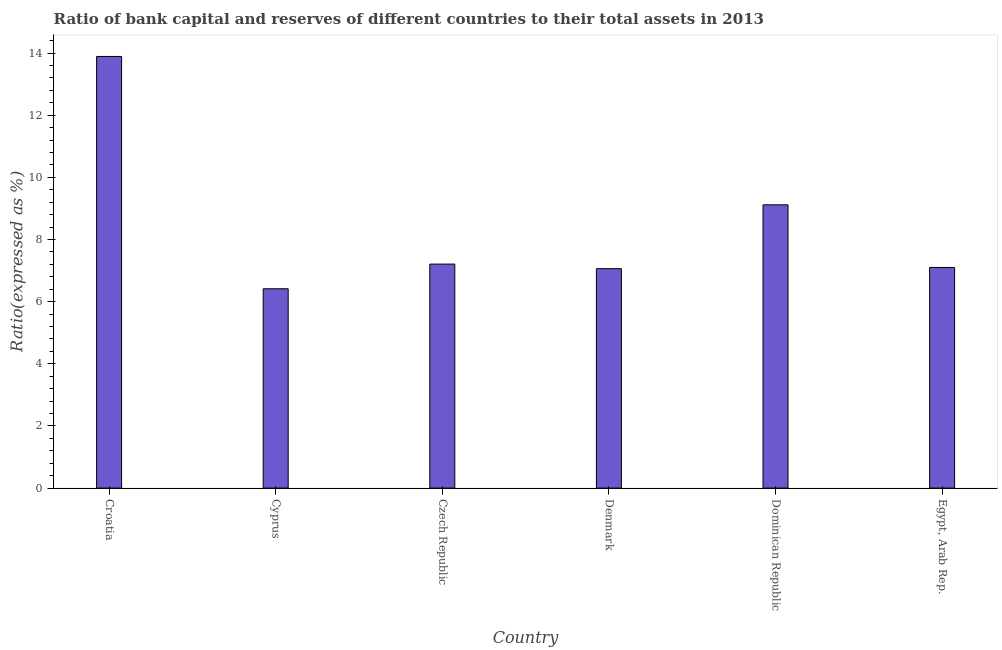Does the graph contain grids?
Provide a succinct answer. No. What is the title of the graph?
Your answer should be compact. Ratio of bank capital and reserves of different countries to their total assets in 2013. What is the label or title of the X-axis?
Make the answer very short. Country. What is the label or title of the Y-axis?
Offer a very short reply. Ratio(expressed as %). What is the bank capital to assets ratio in Croatia?
Make the answer very short. 13.89. Across all countries, what is the maximum bank capital to assets ratio?
Offer a very short reply. 13.89. Across all countries, what is the minimum bank capital to assets ratio?
Provide a succinct answer. 6.41. In which country was the bank capital to assets ratio maximum?
Provide a succinct answer. Croatia. In which country was the bank capital to assets ratio minimum?
Your answer should be very brief. Cyprus. What is the sum of the bank capital to assets ratio?
Keep it short and to the point. 50.79. What is the difference between the bank capital to assets ratio in Dominican Republic and Egypt, Arab Rep.?
Your response must be concise. 2.02. What is the average bank capital to assets ratio per country?
Provide a succinct answer. 8.46. What is the median bank capital to assets ratio?
Your answer should be very brief. 7.15. What is the ratio of the bank capital to assets ratio in Croatia to that in Dominican Republic?
Ensure brevity in your answer.  1.52. What is the difference between the highest and the second highest bank capital to assets ratio?
Provide a succinct answer. 4.78. Is the sum of the bank capital to assets ratio in Denmark and Dominican Republic greater than the maximum bank capital to assets ratio across all countries?
Offer a very short reply. Yes. What is the difference between the highest and the lowest bank capital to assets ratio?
Your answer should be compact. 7.48. In how many countries, is the bank capital to assets ratio greater than the average bank capital to assets ratio taken over all countries?
Your answer should be very brief. 2. How many countries are there in the graph?
Your response must be concise. 6. What is the Ratio(expressed as %) in Croatia?
Your answer should be compact. 13.89. What is the Ratio(expressed as %) in Cyprus?
Your answer should be very brief. 6.41. What is the Ratio(expressed as %) in Czech Republic?
Your answer should be compact. 7.21. What is the Ratio(expressed as %) in Denmark?
Offer a terse response. 7.06. What is the Ratio(expressed as %) of Dominican Republic?
Offer a terse response. 9.12. What is the difference between the Ratio(expressed as %) in Croatia and Cyprus?
Offer a very short reply. 7.48. What is the difference between the Ratio(expressed as %) in Croatia and Czech Republic?
Offer a terse response. 6.68. What is the difference between the Ratio(expressed as %) in Croatia and Denmark?
Your answer should be compact. 6.83. What is the difference between the Ratio(expressed as %) in Croatia and Dominican Republic?
Provide a short and direct response. 4.77. What is the difference between the Ratio(expressed as %) in Croatia and Egypt, Arab Rep.?
Provide a succinct answer. 6.79. What is the difference between the Ratio(expressed as %) in Cyprus and Czech Republic?
Provide a short and direct response. -0.79. What is the difference between the Ratio(expressed as %) in Cyprus and Denmark?
Offer a terse response. -0.65. What is the difference between the Ratio(expressed as %) in Cyprus and Dominican Republic?
Your response must be concise. -2.7. What is the difference between the Ratio(expressed as %) in Cyprus and Egypt, Arab Rep.?
Make the answer very short. -0.69. What is the difference between the Ratio(expressed as %) in Czech Republic and Denmark?
Ensure brevity in your answer.  0.15. What is the difference between the Ratio(expressed as %) in Czech Republic and Dominican Republic?
Keep it short and to the point. -1.91. What is the difference between the Ratio(expressed as %) in Czech Republic and Egypt, Arab Rep.?
Give a very brief answer. 0.11. What is the difference between the Ratio(expressed as %) in Denmark and Dominican Republic?
Give a very brief answer. -2.05. What is the difference between the Ratio(expressed as %) in Denmark and Egypt, Arab Rep.?
Provide a succinct answer. -0.04. What is the difference between the Ratio(expressed as %) in Dominican Republic and Egypt, Arab Rep.?
Keep it short and to the point. 2.02. What is the ratio of the Ratio(expressed as %) in Croatia to that in Cyprus?
Provide a short and direct response. 2.17. What is the ratio of the Ratio(expressed as %) in Croatia to that in Czech Republic?
Make the answer very short. 1.93. What is the ratio of the Ratio(expressed as %) in Croatia to that in Denmark?
Give a very brief answer. 1.97. What is the ratio of the Ratio(expressed as %) in Croatia to that in Dominican Republic?
Your response must be concise. 1.52. What is the ratio of the Ratio(expressed as %) in Croatia to that in Egypt, Arab Rep.?
Offer a very short reply. 1.96. What is the ratio of the Ratio(expressed as %) in Cyprus to that in Czech Republic?
Offer a very short reply. 0.89. What is the ratio of the Ratio(expressed as %) in Cyprus to that in Denmark?
Offer a terse response. 0.91. What is the ratio of the Ratio(expressed as %) in Cyprus to that in Dominican Republic?
Provide a succinct answer. 0.7. What is the ratio of the Ratio(expressed as %) in Cyprus to that in Egypt, Arab Rep.?
Offer a terse response. 0.9. What is the ratio of the Ratio(expressed as %) in Czech Republic to that in Dominican Republic?
Ensure brevity in your answer.  0.79. What is the ratio of the Ratio(expressed as %) in Denmark to that in Dominican Republic?
Make the answer very short. 0.78. What is the ratio of the Ratio(expressed as %) in Denmark to that in Egypt, Arab Rep.?
Keep it short and to the point. 0.99. What is the ratio of the Ratio(expressed as %) in Dominican Republic to that in Egypt, Arab Rep.?
Your answer should be very brief. 1.28. 